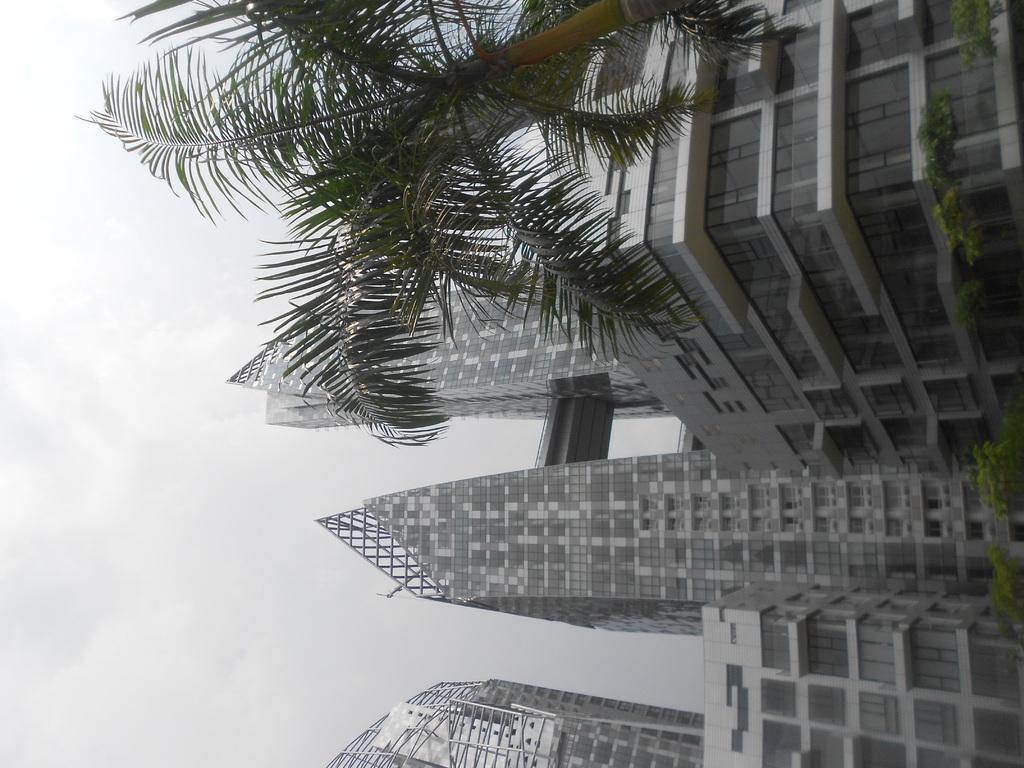Could you give a brief overview of what you see in this image? In this image we can see group of buildings ,trees and in the background ,we can see the sky. 